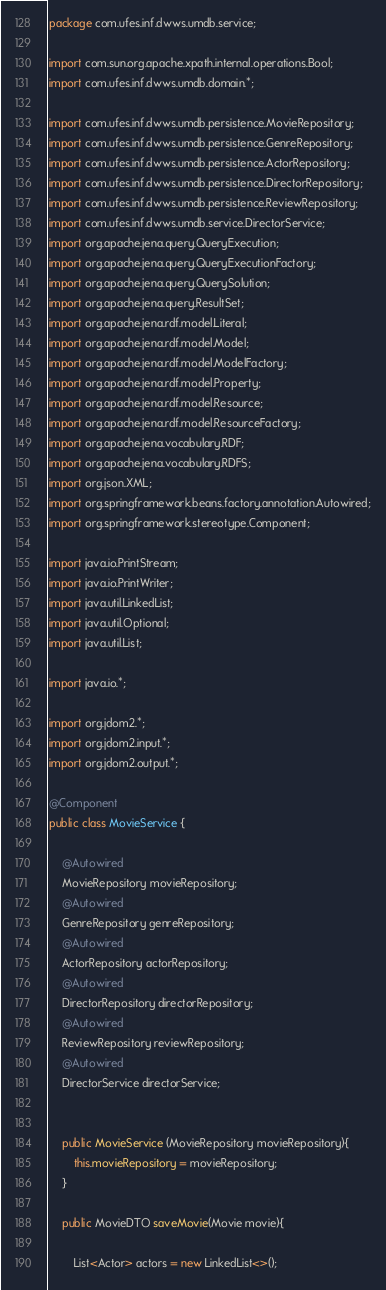Convert code to text. <code><loc_0><loc_0><loc_500><loc_500><_Java_>package com.ufes.inf.dwws.umdb.service;

import com.sun.org.apache.xpath.internal.operations.Bool;
import com.ufes.inf.dwws.umdb.domain.*;

import com.ufes.inf.dwws.umdb.persistence.MovieRepository;
import com.ufes.inf.dwws.umdb.persistence.GenreRepository;
import com.ufes.inf.dwws.umdb.persistence.ActorRepository;
import com.ufes.inf.dwws.umdb.persistence.DirectorRepository;
import com.ufes.inf.dwws.umdb.persistence.ReviewRepository;
import com.ufes.inf.dwws.umdb.service.DirectorService;
import org.apache.jena.query.QueryExecution;
import org.apache.jena.query.QueryExecutionFactory;
import org.apache.jena.query.QuerySolution;
import org.apache.jena.query.ResultSet;
import org.apache.jena.rdf.model.Literal;
import org.apache.jena.rdf.model.Model;
import org.apache.jena.rdf.model.ModelFactory;
import org.apache.jena.rdf.model.Property;
import org.apache.jena.rdf.model.Resource;
import org.apache.jena.rdf.model.ResourceFactory;
import org.apache.jena.vocabulary.RDF;
import org.apache.jena.vocabulary.RDFS;
import org.json.XML;
import org.springframework.beans.factory.annotation.Autowired;
import org.springframework.stereotype.Component;

import java.io.PrintStream;
import java.io.PrintWriter;
import java.util.LinkedList;
import java.util.Optional;
import java.util.List;

import java.io.*;

import org.jdom2.*;
import org.jdom2.input.*;
import org.jdom2.output.*;

@Component
public class MovieService {

    @Autowired
    MovieRepository movieRepository;
    @Autowired
    GenreRepository genreRepository;
    @Autowired
    ActorRepository actorRepository;
    @Autowired
    DirectorRepository directorRepository;
    @Autowired
    ReviewRepository reviewRepository;
    @Autowired
    DirectorService directorService;


    public MovieService (MovieRepository movieRepository){
        this.movieRepository = movieRepository;
    }

    public MovieDTO saveMovie(Movie movie){

        List<Actor> actors = new LinkedList<>();</code> 